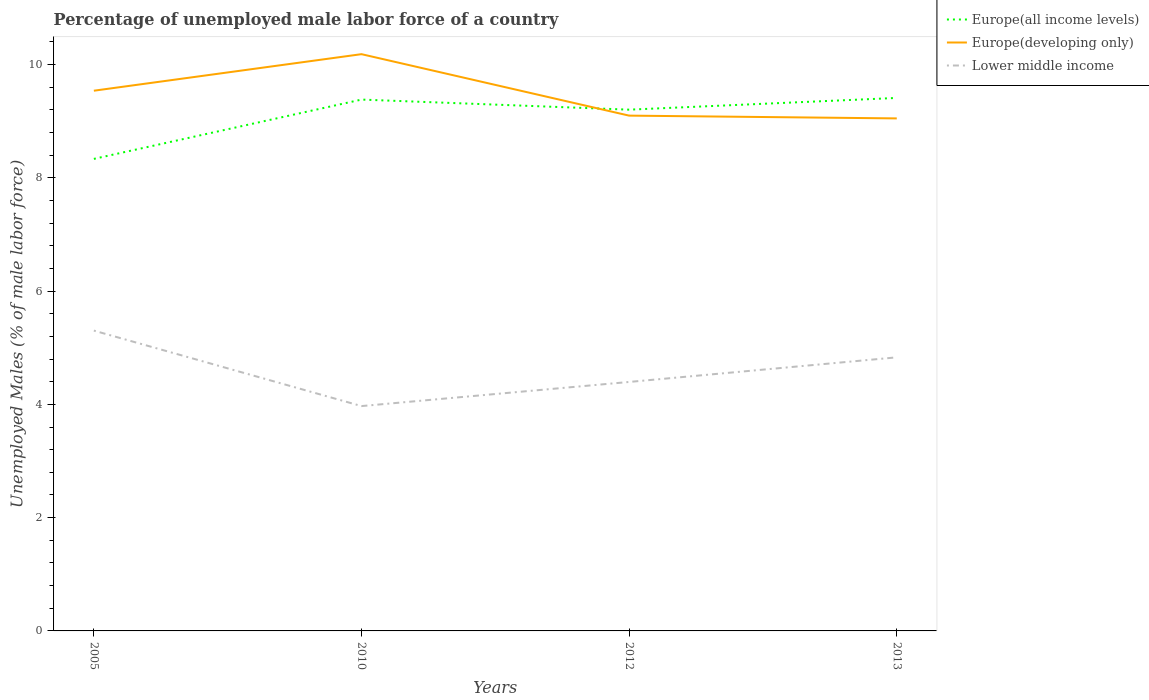How many different coloured lines are there?
Ensure brevity in your answer.  3. Does the line corresponding to Europe(developing only) intersect with the line corresponding to Lower middle income?
Make the answer very short. No. Is the number of lines equal to the number of legend labels?
Make the answer very short. Yes. Across all years, what is the maximum percentage of unemployed male labor force in Europe(all income levels)?
Provide a short and direct response. 8.33. In which year was the percentage of unemployed male labor force in Europe(developing only) maximum?
Your answer should be very brief. 2013. What is the total percentage of unemployed male labor force in Europe(developing only) in the graph?
Your answer should be compact. 0.44. What is the difference between the highest and the second highest percentage of unemployed male labor force in Europe(developing only)?
Your answer should be compact. 1.13. What is the difference between the highest and the lowest percentage of unemployed male labor force in Europe(developing only)?
Your answer should be compact. 2. How many years are there in the graph?
Provide a succinct answer. 4. What is the difference between two consecutive major ticks on the Y-axis?
Keep it short and to the point. 2. Are the values on the major ticks of Y-axis written in scientific E-notation?
Give a very brief answer. No. Does the graph contain any zero values?
Provide a succinct answer. No. Does the graph contain grids?
Offer a terse response. No. Where does the legend appear in the graph?
Keep it short and to the point. Top right. How are the legend labels stacked?
Offer a very short reply. Vertical. What is the title of the graph?
Make the answer very short. Percentage of unemployed male labor force of a country. What is the label or title of the Y-axis?
Keep it short and to the point. Unemployed Males (% of male labor force). What is the Unemployed Males (% of male labor force) in Europe(all income levels) in 2005?
Keep it short and to the point. 8.33. What is the Unemployed Males (% of male labor force) in Europe(developing only) in 2005?
Give a very brief answer. 9.54. What is the Unemployed Males (% of male labor force) in Lower middle income in 2005?
Your answer should be compact. 5.3. What is the Unemployed Males (% of male labor force) in Europe(all income levels) in 2010?
Give a very brief answer. 9.38. What is the Unemployed Males (% of male labor force) of Europe(developing only) in 2010?
Your answer should be very brief. 10.18. What is the Unemployed Males (% of male labor force) of Lower middle income in 2010?
Ensure brevity in your answer.  3.97. What is the Unemployed Males (% of male labor force) of Europe(all income levels) in 2012?
Offer a very short reply. 9.2. What is the Unemployed Males (% of male labor force) in Europe(developing only) in 2012?
Give a very brief answer. 9.1. What is the Unemployed Males (% of male labor force) in Lower middle income in 2012?
Provide a short and direct response. 4.4. What is the Unemployed Males (% of male labor force) in Europe(all income levels) in 2013?
Provide a succinct answer. 9.41. What is the Unemployed Males (% of male labor force) of Europe(developing only) in 2013?
Provide a short and direct response. 9.05. What is the Unemployed Males (% of male labor force) of Lower middle income in 2013?
Your answer should be very brief. 4.83. Across all years, what is the maximum Unemployed Males (% of male labor force) in Europe(all income levels)?
Your answer should be compact. 9.41. Across all years, what is the maximum Unemployed Males (% of male labor force) of Europe(developing only)?
Give a very brief answer. 10.18. Across all years, what is the maximum Unemployed Males (% of male labor force) in Lower middle income?
Ensure brevity in your answer.  5.3. Across all years, what is the minimum Unemployed Males (% of male labor force) of Europe(all income levels)?
Provide a short and direct response. 8.33. Across all years, what is the minimum Unemployed Males (% of male labor force) of Europe(developing only)?
Make the answer very short. 9.05. Across all years, what is the minimum Unemployed Males (% of male labor force) of Lower middle income?
Your answer should be very brief. 3.97. What is the total Unemployed Males (% of male labor force) in Europe(all income levels) in the graph?
Your answer should be compact. 36.33. What is the total Unemployed Males (% of male labor force) of Europe(developing only) in the graph?
Give a very brief answer. 37.87. What is the total Unemployed Males (% of male labor force) in Lower middle income in the graph?
Offer a terse response. 18.5. What is the difference between the Unemployed Males (% of male labor force) in Europe(all income levels) in 2005 and that in 2010?
Offer a terse response. -1.05. What is the difference between the Unemployed Males (% of male labor force) in Europe(developing only) in 2005 and that in 2010?
Provide a succinct answer. -0.65. What is the difference between the Unemployed Males (% of male labor force) in Lower middle income in 2005 and that in 2010?
Provide a short and direct response. 1.33. What is the difference between the Unemployed Males (% of male labor force) in Europe(all income levels) in 2005 and that in 2012?
Offer a terse response. -0.87. What is the difference between the Unemployed Males (% of male labor force) in Europe(developing only) in 2005 and that in 2012?
Make the answer very short. 0.44. What is the difference between the Unemployed Males (% of male labor force) of Lower middle income in 2005 and that in 2012?
Give a very brief answer. 0.91. What is the difference between the Unemployed Males (% of male labor force) in Europe(all income levels) in 2005 and that in 2013?
Give a very brief answer. -1.08. What is the difference between the Unemployed Males (% of male labor force) of Europe(developing only) in 2005 and that in 2013?
Your answer should be very brief. 0.49. What is the difference between the Unemployed Males (% of male labor force) in Lower middle income in 2005 and that in 2013?
Provide a succinct answer. 0.47. What is the difference between the Unemployed Males (% of male labor force) in Europe(all income levels) in 2010 and that in 2012?
Your answer should be very brief. 0.18. What is the difference between the Unemployed Males (% of male labor force) of Europe(developing only) in 2010 and that in 2012?
Offer a very short reply. 1.09. What is the difference between the Unemployed Males (% of male labor force) in Lower middle income in 2010 and that in 2012?
Provide a succinct answer. -0.43. What is the difference between the Unemployed Males (% of male labor force) in Europe(all income levels) in 2010 and that in 2013?
Provide a short and direct response. -0.03. What is the difference between the Unemployed Males (% of male labor force) in Europe(developing only) in 2010 and that in 2013?
Make the answer very short. 1.13. What is the difference between the Unemployed Males (% of male labor force) of Lower middle income in 2010 and that in 2013?
Offer a very short reply. -0.86. What is the difference between the Unemployed Males (% of male labor force) of Europe(all income levels) in 2012 and that in 2013?
Ensure brevity in your answer.  -0.21. What is the difference between the Unemployed Males (% of male labor force) of Europe(developing only) in 2012 and that in 2013?
Provide a succinct answer. 0.05. What is the difference between the Unemployed Males (% of male labor force) in Lower middle income in 2012 and that in 2013?
Your response must be concise. -0.43. What is the difference between the Unemployed Males (% of male labor force) of Europe(all income levels) in 2005 and the Unemployed Males (% of male labor force) of Europe(developing only) in 2010?
Your answer should be compact. -1.85. What is the difference between the Unemployed Males (% of male labor force) of Europe(all income levels) in 2005 and the Unemployed Males (% of male labor force) of Lower middle income in 2010?
Your response must be concise. 4.36. What is the difference between the Unemployed Males (% of male labor force) of Europe(developing only) in 2005 and the Unemployed Males (% of male labor force) of Lower middle income in 2010?
Make the answer very short. 5.57. What is the difference between the Unemployed Males (% of male labor force) of Europe(all income levels) in 2005 and the Unemployed Males (% of male labor force) of Europe(developing only) in 2012?
Offer a terse response. -0.76. What is the difference between the Unemployed Males (% of male labor force) of Europe(all income levels) in 2005 and the Unemployed Males (% of male labor force) of Lower middle income in 2012?
Provide a short and direct response. 3.94. What is the difference between the Unemployed Males (% of male labor force) in Europe(developing only) in 2005 and the Unemployed Males (% of male labor force) in Lower middle income in 2012?
Give a very brief answer. 5.14. What is the difference between the Unemployed Males (% of male labor force) in Europe(all income levels) in 2005 and the Unemployed Males (% of male labor force) in Europe(developing only) in 2013?
Ensure brevity in your answer.  -0.71. What is the difference between the Unemployed Males (% of male labor force) of Europe(all income levels) in 2005 and the Unemployed Males (% of male labor force) of Lower middle income in 2013?
Make the answer very short. 3.5. What is the difference between the Unemployed Males (% of male labor force) in Europe(developing only) in 2005 and the Unemployed Males (% of male labor force) in Lower middle income in 2013?
Your response must be concise. 4.71. What is the difference between the Unemployed Males (% of male labor force) of Europe(all income levels) in 2010 and the Unemployed Males (% of male labor force) of Europe(developing only) in 2012?
Keep it short and to the point. 0.28. What is the difference between the Unemployed Males (% of male labor force) in Europe(all income levels) in 2010 and the Unemployed Males (% of male labor force) in Lower middle income in 2012?
Give a very brief answer. 4.99. What is the difference between the Unemployed Males (% of male labor force) in Europe(developing only) in 2010 and the Unemployed Males (% of male labor force) in Lower middle income in 2012?
Offer a terse response. 5.79. What is the difference between the Unemployed Males (% of male labor force) in Europe(all income levels) in 2010 and the Unemployed Males (% of male labor force) in Europe(developing only) in 2013?
Your answer should be compact. 0.33. What is the difference between the Unemployed Males (% of male labor force) of Europe(all income levels) in 2010 and the Unemployed Males (% of male labor force) of Lower middle income in 2013?
Offer a very short reply. 4.55. What is the difference between the Unemployed Males (% of male labor force) of Europe(developing only) in 2010 and the Unemployed Males (% of male labor force) of Lower middle income in 2013?
Your response must be concise. 5.35. What is the difference between the Unemployed Males (% of male labor force) in Europe(all income levels) in 2012 and the Unemployed Males (% of male labor force) in Europe(developing only) in 2013?
Make the answer very short. 0.15. What is the difference between the Unemployed Males (% of male labor force) in Europe(all income levels) in 2012 and the Unemployed Males (% of male labor force) in Lower middle income in 2013?
Offer a terse response. 4.37. What is the difference between the Unemployed Males (% of male labor force) in Europe(developing only) in 2012 and the Unemployed Males (% of male labor force) in Lower middle income in 2013?
Make the answer very short. 4.27. What is the average Unemployed Males (% of male labor force) of Europe(all income levels) per year?
Your answer should be compact. 9.08. What is the average Unemployed Males (% of male labor force) of Europe(developing only) per year?
Your answer should be very brief. 9.47. What is the average Unemployed Males (% of male labor force) of Lower middle income per year?
Provide a short and direct response. 4.62. In the year 2005, what is the difference between the Unemployed Males (% of male labor force) in Europe(all income levels) and Unemployed Males (% of male labor force) in Europe(developing only)?
Your response must be concise. -1.2. In the year 2005, what is the difference between the Unemployed Males (% of male labor force) of Europe(all income levels) and Unemployed Males (% of male labor force) of Lower middle income?
Your response must be concise. 3.03. In the year 2005, what is the difference between the Unemployed Males (% of male labor force) in Europe(developing only) and Unemployed Males (% of male labor force) in Lower middle income?
Keep it short and to the point. 4.24. In the year 2010, what is the difference between the Unemployed Males (% of male labor force) in Europe(all income levels) and Unemployed Males (% of male labor force) in Europe(developing only)?
Offer a terse response. -0.8. In the year 2010, what is the difference between the Unemployed Males (% of male labor force) in Europe(all income levels) and Unemployed Males (% of male labor force) in Lower middle income?
Ensure brevity in your answer.  5.41. In the year 2010, what is the difference between the Unemployed Males (% of male labor force) in Europe(developing only) and Unemployed Males (% of male labor force) in Lower middle income?
Make the answer very short. 6.21. In the year 2012, what is the difference between the Unemployed Males (% of male labor force) of Europe(all income levels) and Unemployed Males (% of male labor force) of Europe(developing only)?
Make the answer very short. 0.11. In the year 2012, what is the difference between the Unemployed Males (% of male labor force) of Europe(all income levels) and Unemployed Males (% of male labor force) of Lower middle income?
Provide a succinct answer. 4.81. In the year 2012, what is the difference between the Unemployed Males (% of male labor force) in Europe(developing only) and Unemployed Males (% of male labor force) in Lower middle income?
Provide a succinct answer. 4.7. In the year 2013, what is the difference between the Unemployed Males (% of male labor force) of Europe(all income levels) and Unemployed Males (% of male labor force) of Europe(developing only)?
Offer a very short reply. 0.36. In the year 2013, what is the difference between the Unemployed Males (% of male labor force) of Europe(all income levels) and Unemployed Males (% of male labor force) of Lower middle income?
Provide a succinct answer. 4.58. In the year 2013, what is the difference between the Unemployed Males (% of male labor force) of Europe(developing only) and Unemployed Males (% of male labor force) of Lower middle income?
Provide a succinct answer. 4.22. What is the ratio of the Unemployed Males (% of male labor force) in Europe(all income levels) in 2005 to that in 2010?
Keep it short and to the point. 0.89. What is the ratio of the Unemployed Males (% of male labor force) in Europe(developing only) in 2005 to that in 2010?
Ensure brevity in your answer.  0.94. What is the ratio of the Unemployed Males (% of male labor force) in Lower middle income in 2005 to that in 2010?
Your response must be concise. 1.34. What is the ratio of the Unemployed Males (% of male labor force) of Europe(all income levels) in 2005 to that in 2012?
Your response must be concise. 0.91. What is the ratio of the Unemployed Males (% of male labor force) in Europe(developing only) in 2005 to that in 2012?
Provide a succinct answer. 1.05. What is the ratio of the Unemployed Males (% of male labor force) in Lower middle income in 2005 to that in 2012?
Offer a terse response. 1.21. What is the ratio of the Unemployed Males (% of male labor force) in Europe(all income levels) in 2005 to that in 2013?
Offer a terse response. 0.89. What is the ratio of the Unemployed Males (% of male labor force) of Europe(developing only) in 2005 to that in 2013?
Provide a short and direct response. 1.05. What is the ratio of the Unemployed Males (% of male labor force) of Lower middle income in 2005 to that in 2013?
Your answer should be compact. 1.1. What is the ratio of the Unemployed Males (% of male labor force) in Europe(all income levels) in 2010 to that in 2012?
Give a very brief answer. 1.02. What is the ratio of the Unemployed Males (% of male labor force) in Europe(developing only) in 2010 to that in 2012?
Provide a succinct answer. 1.12. What is the ratio of the Unemployed Males (% of male labor force) of Lower middle income in 2010 to that in 2012?
Provide a short and direct response. 0.9. What is the ratio of the Unemployed Males (% of male labor force) of Europe(developing only) in 2010 to that in 2013?
Provide a succinct answer. 1.13. What is the ratio of the Unemployed Males (% of male labor force) of Lower middle income in 2010 to that in 2013?
Make the answer very short. 0.82. What is the ratio of the Unemployed Males (% of male labor force) of Europe(all income levels) in 2012 to that in 2013?
Offer a very short reply. 0.98. What is the ratio of the Unemployed Males (% of male labor force) of Europe(developing only) in 2012 to that in 2013?
Make the answer very short. 1.01. What is the ratio of the Unemployed Males (% of male labor force) of Lower middle income in 2012 to that in 2013?
Offer a very short reply. 0.91. What is the difference between the highest and the second highest Unemployed Males (% of male labor force) in Europe(all income levels)?
Provide a succinct answer. 0.03. What is the difference between the highest and the second highest Unemployed Males (% of male labor force) in Europe(developing only)?
Keep it short and to the point. 0.65. What is the difference between the highest and the second highest Unemployed Males (% of male labor force) of Lower middle income?
Ensure brevity in your answer.  0.47. What is the difference between the highest and the lowest Unemployed Males (% of male labor force) of Europe(all income levels)?
Make the answer very short. 1.08. What is the difference between the highest and the lowest Unemployed Males (% of male labor force) of Europe(developing only)?
Provide a short and direct response. 1.13. What is the difference between the highest and the lowest Unemployed Males (% of male labor force) of Lower middle income?
Give a very brief answer. 1.33. 